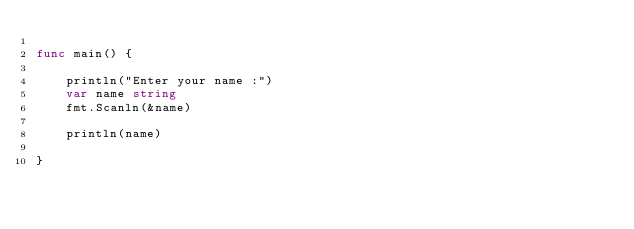Convert code to text. <code><loc_0><loc_0><loc_500><loc_500><_Go_>
func main() {

	println("Enter your name :")
	var name string
	fmt.Scanln(&name)

	println(name)

}
</code> 